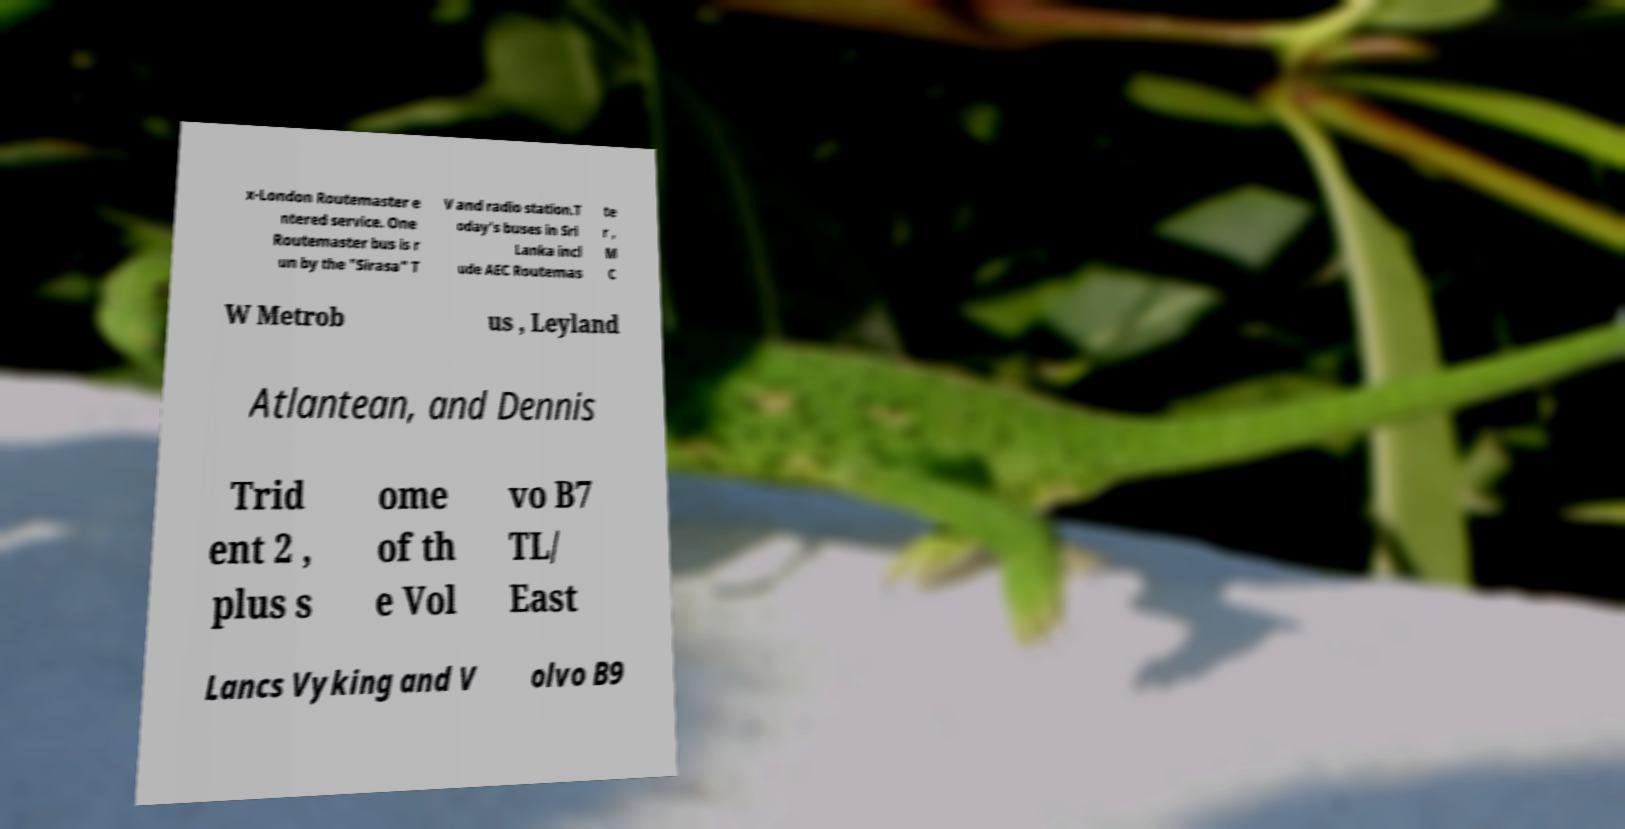Could you assist in decoding the text presented in this image and type it out clearly? x-London Routemaster e ntered service. One Routemaster bus is r un by the "Sirasa" T V and radio station.T oday's buses in Sri Lanka incl ude AEC Routemas te r , M C W Metrob us , Leyland Atlantean, and Dennis Trid ent 2 , plus s ome of th e Vol vo B7 TL/ East Lancs Vyking and V olvo B9 